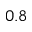<formula> <loc_0><loc_0><loc_500><loc_500>0 . 8</formula> 